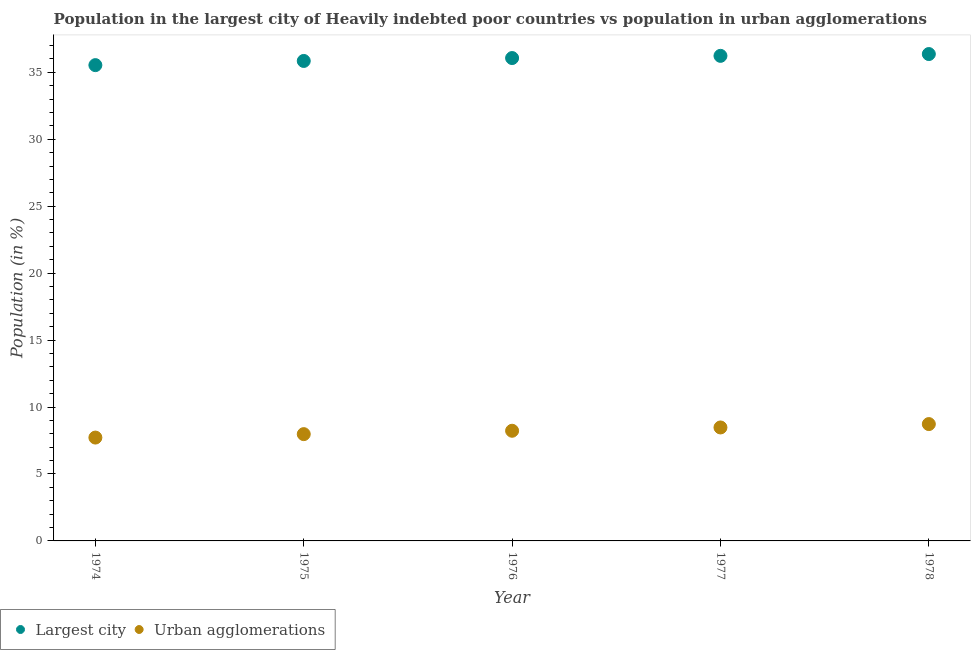Is the number of dotlines equal to the number of legend labels?
Provide a short and direct response. Yes. What is the population in urban agglomerations in 1978?
Your answer should be compact. 8.73. Across all years, what is the maximum population in urban agglomerations?
Offer a terse response. 8.73. Across all years, what is the minimum population in the largest city?
Your answer should be compact. 35.54. In which year was the population in the largest city maximum?
Ensure brevity in your answer.  1978. In which year was the population in urban agglomerations minimum?
Make the answer very short. 1974. What is the total population in urban agglomerations in the graph?
Provide a succinct answer. 41.12. What is the difference between the population in urban agglomerations in 1975 and that in 1977?
Offer a terse response. -0.5. What is the difference between the population in urban agglomerations in 1975 and the population in the largest city in 1974?
Your response must be concise. -27.56. What is the average population in the largest city per year?
Keep it short and to the point. 36.01. In the year 1974, what is the difference between the population in the largest city and population in urban agglomerations?
Provide a short and direct response. 27.82. In how many years, is the population in the largest city greater than 34 %?
Give a very brief answer. 5. What is the ratio of the population in urban agglomerations in 1976 to that in 1978?
Offer a very short reply. 0.94. Is the population in the largest city in 1974 less than that in 1977?
Offer a very short reply. Yes. What is the difference between the highest and the second highest population in the largest city?
Ensure brevity in your answer.  0.13. What is the difference between the highest and the lowest population in the largest city?
Your answer should be very brief. 0.83. Is the sum of the population in the largest city in 1975 and 1977 greater than the maximum population in urban agglomerations across all years?
Provide a short and direct response. Yes. Does the population in urban agglomerations monotonically increase over the years?
Make the answer very short. Yes. Are the values on the major ticks of Y-axis written in scientific E-notation?
Provide a short and direct response. No. Does the graph contain any zero values?
Keep it short and to the point. No. Does the graph contain grids?
Your answer should be compact. No. Where does the legend appear in the graph?
Give a very brief answer. Bottom left. How many legend labels are there?
Make the answer very short. 2. How are the legend labels stacked?
Provide a short and direct response. Horizontal. What is the title of the graph?
Provide a short and direct response. Population in the largest city of Heavily indebted poor countries vs population in urban agglomerations. What is the Population (in %) in Largest city in 1974?
Offer a terse response. 35.54. What is the Population (in %) in Urban agglomerations in 1974?
Your answer should be very brief. 7.72. What is the Population (in %) in Largest city in 1975?
Provide a short and direct response. 35.85. What is the Population (in %) in Urban agglomerations in 1975?
Ensure brevity in your answer.  7.98. What is the Population (in %) of Largest city in 1976?
Your response must be concise. 36.07. What is the Population (in %) in Urban agglomerations in 1976?
Give a very brief answer. 8.23. What is the Population (in %) of Largest city in 1977?
Make the answer very short. 36.23. What is the Population (in %) of Urban agglomerations in 1977?
Keep it short and to the point. 8.47. What is the Population (in %) in Largest city in 1978?
Your response must be concise. 36.36. What is the Population (in %) in Urban agglomerations in 1978?
Provide a succinct answer. 8.73. Across all years, what is the maximum Population (in %) in Largest city?
Make the answer very short. 36.36. Across all years, what is the maximum Population (in %) of Urban agglomerations?
Ensure brevity in your answer.  8.73. Across all years, what is the minimum Population (in %) in Largest city?
Your answer should be compact. 35.54. Across all years, what is the minimum Population (in %) in Urban agglomerations?
Keep it short and to the point. 7.72. What is the total Population (in %) of Largest city in the graph?
Give a very brief answer. 180.05. What is the total Population (in %) in Urban agglomerations in the graph?
Make the answer very short. 41.12. What is the difference between the Population (in %) of Largest city in 1974 and that in 1975?
Your response must be concise. -0.31. What is the difference between the Population (in %) in Urban agglomerations in 1974 and that in 1975?
Keep it short and to the point. -0.26. What is the difference between the Population (in %) in Largest city in 1974 and that in 1976?
Make the answer very short. -0.53. What is the difference between the Population (in %) of Urban agglomerations in 1974 and that in 1976?
Your answer should be compact. -0.51. What is the difference between the Population (in %) in Largest city in 1974 and that in 1977?
Make the answer very short. -0.69. What is the difference between the Population (in %) of Urban agglomerations in 1974 and that in 1977?
Keep it short and to the point. -0.76. What is the difference between the Population (in %) of Largest city in 1974 and that in 1978?
Your answer should be very brief. -0.83. What is the difference between the Population (in %) in Urban agglomerations in 1974 and that in 1978?
Your answer should be very brief. -1.01. What is the difference between the Population (in %) in Largest city in 1975 and that in 1976?
Offer a very short reply. -0.22. What is the difference between the Population (in %) in Urban agglomerations in 1975 and that in 1976?
Make the answer very short. -0.25. What is the difference between the Population (in %) in Largest city in 1975 and that in 1977?
Your response must be concise. -0.38. What is the difference between the Population (in %) of Urban agglomerations in 1975 and that in 1977?
Offer a terse response. -0.5. What is the difference between the Population (in %) of Largest city in 1975 and that in 1978?
Offer a terse response. -0.52. What is the difference between the Population (in %) of Urban agglomerations in 1975 and that in 1978?
Keep it short and to the point. -0.75. What is the difference between the Population (in %) in Largest city in 1976 and that in 1977?
Provide a succinct answer. -0.16. What is the difference between the Population (in %) of Urban agglomerations in 1976 and that in 1977?
Offer a very short reply. -0.25. What is the difference between the Population (in %) in Largest city in 1976 and that in 1978?
Your response must be concise. -0.3. What is the difference between the Population (in %) in Urban agglomerations in 1976 and that in 1978?
Your answer should be compact. -0.5. What is the difference between the Population (in %) of Largest city in 1977 and that in 1978?
Keep it short and to the point. -0.13. What is the difference between the Population (in %) of Urban agglomerations in 1977 and that in 1978?
Give a very brief answer. -0.25. What is the difference between the Population (in %) of Largest city in 1974 and the Population (in %) of Urban agglomerations in 1975?
Provide a succinct answer. 27.56. What is the difference between the Population (in %) of Largest city in 1974 and the Population (in %) of Urban agglomerations in 1976?
Keep it short and to the point. 27.31. What is the difference between the Population (in %) in Largest city in 1974 and the Population (in %) in Urban agglomerations in 1977?
Your answer should be very brief. 27.06. What is the difference between the Population (in %) of Largest city in 1974 and the Population (in %) of Urban agglomerations in 1978?
Your answer should be very brief. 26.81. What is the difference between the Population (in %) in Largest city in 1975 and the Population (in %) in Urban agglomerations in 1976?
Ensure brevity in your answer.  27.62. What is the difference between the Population (in %) in Largest city in 1975 and the Population (in %) in Urban agglomerations in 1977?
Provide a succinct answer. 27.37. What is the difference between the Population (in %) in Largest city in 1975 and the Population (in %) in Urban agglomerations in 1978?
Provide a short and direct response. 27.12. What is the difference between the Population (in %) in Largest city in 1976 and the Population (in %) in Urban agglomerations in 1977?
Keep it short and to the point. 27.59. What is the difference between the Population (in %) in Largest city in 1976 and the Population (in %) in Urban agglomerations in 1978?
Your answer should be compact. 27.34. What is the difference between the Population (in %) of Largest city in 1977 and the Population (in %) of Urban agglomerations in 1978?
Keep it short and to the point. 27.5. What is the average Population (in %) of Largest city per year?
Offer a terse response. 36.01. What is the average Population (in %) of Urban agglomerations per year?
Make the answer very short. 8.22. In the year 1974, what is the difference between the Population (in %) of Largest city and Population (in %) of Urban agglomerations?
Keep it short and to the point. 27.82. In the year 1975, what is the difference between the Population (in %) in Largest city and Population (in %) in Urban agglomerations?
Give a very brief answer. 27.87. In the year 1976, what is the difference between the Population (in %) in Largest city and Population (in %) in Urban agglomerations?
Provide a succinct answer. 27.84. In the year 1977, what is the difference between the Population (in %) of Largest city and Population (in %) of Urban agglomerations?
Offer a very short reply. 27.76. In the year 1978, what is the difference between the Population (in %) in Largest city and Population (in %) in Urban agglomerations?
Provide a short and direct response. 27.64. What is the ratio of the Population (in %) of Urban agglomerations in 1974 to that in 1975?
Offer a very short reply. 0.97. What is the ratio of the Population (in %) in Urban agglomerations in 1974 to that in 1976?
Give a very brief answer. 0.94. What is the ratio of the Population (in %) in Largest city in 1974 to that in 1977?
Offer a terse response. 0.98. What is the ratio of the Population (in %) of Urban agglomerations in 1974 to that in 1977?
Provide a short and direct response. 0.91. What is the ratio of the Population (in %) in Largest city in 1974 to that in 1978?
Provide a succinct answer. 0.98. What is the ratio of the Population (in %) of Urban agglomerations in 1974 to that in 1978?
Your answer should be very brief. 0.88. What is the ratio of the Population (in %) in Largest city in 1975 to that in 1976?
Give a very brief answer. 0.99. What is the ratio of the Population (in %) of Urban agglomerations in 1975 to that in 1976?
Ensure brevity in your answer.  0.97. What is the ratio of the Population (in %) in Urban agglomerations in 1975 to that in 1977?
Offer a very short reply. 0.94. What is the ratio of the Population (in %) of Largest city in 1975 to that in 1978?
Your response must be concise. 0.99. What is the ratio of the Population (in %) in Urban agglomerations in 1975 to that in 1978?
Keep it short and to the point. 0.91. What is the ratio of the Population (in %) of Largest city in 1976 to that in 1977?
Keep it short and to the point. 1. What is the ratio of the Population (in %) of Urban agglomerations in 1976 to that in 1977?
Offer a very short reply. 0.97. What is the ratio of the Population (in %) in Urban agglomerations in 1976 to that in 1978?
Provide a succinct answer. 0.94. What is the ratio of the Population (in %) of Urban agglomerations in 1977 to that in 1978?
Offer a terse response. 0.97. What is the difference between the highest and the second highest Population (in %) of Largest city?
Ensure brevity in your answer.  0.13. What is the difference between the highest and the second highest Population (in %) in Urban agglomerations?
Ensure brevity in your answer.  0.25. What is the difference between the highest and the lowest Population (in %) of Largest city?
Make the answer very short. 0.83. What is the difference between the highest and the lowest Population (in %) of Urban agglomerations?
Your answer should be very brief. 1.01. 